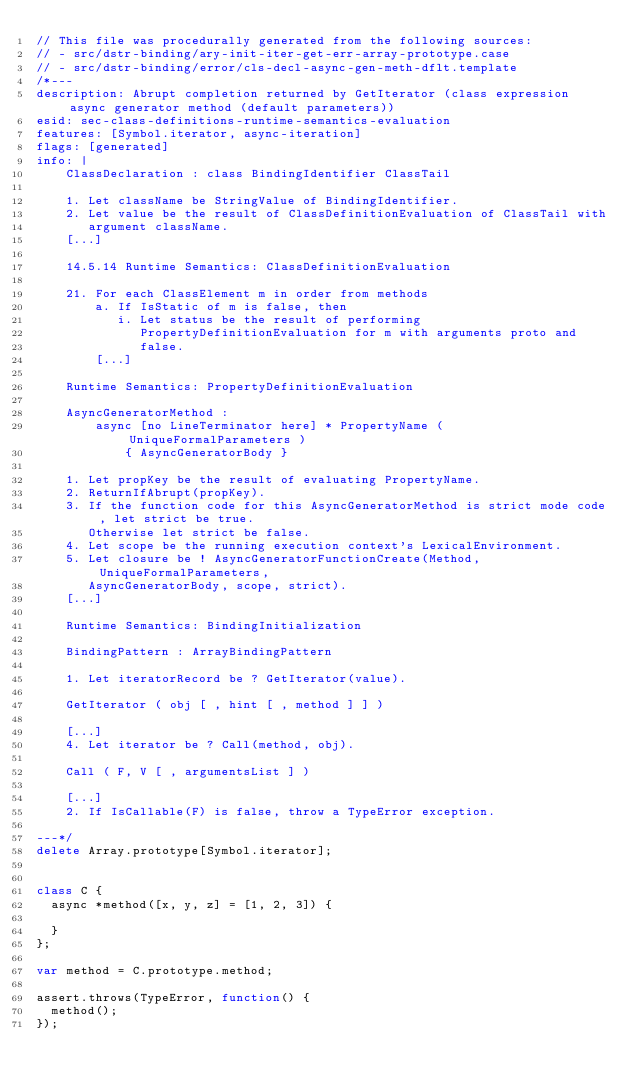<code> <loc_0><loc_0><loc_500><loc_500><_JavaScript_>// This file was procedurally generated from the following sources:
// - src/dstr-binding/ary-init-iter-get-err-array-prototype.case
// - src/dstr-binding/error/cls-decl-async-gen-meth-dflt.template
/*---
description: Abrupt completion returned by GetIterator (class expression async generator method (default parameters))
esid: sec-class-definitions-runtime-semantics-evaluation
features: [Symbol.iterator, async-iteration]
flags: [generated]
info: |
    ClassDeclaration : class BindingIdentifier ClassTail

    1. Let className be StringValue of BindingIdentifier.
    2. Let value be the result of ClassDefinitionEvaluation of ClassTail with
       argument className.
    [...]

    14.5.14 Runtime Semantics: ClassDefinitionEvaluation

    21. For each ClassElement m in order from methods
        a. If IsStatic of m is false, then
           i. Let status be the result of performing
              PropertyDefinitionEvaluation for m with arguments proto and
              false.
        [...]

    Runtime Semantics: PropertyDefinitionEvaluation

    AsyncGeneratorMethod :
        async [no LineTerminator here] * PropertyName ( UniqueFormalParameters )
            { AsyncGeneratorBody }

    1. Let propKey be the result of evaluating PropertyName.
    2. ReturnIfAbrupt(propKey).
    3. If the function code for this AsyncGeneratorMethod is strict mode code, let strict be true.
       Otherwise let strict be false.
    4. Let scope be the running execution context's LexicalEnvironment.
    5. Let closure be ! AsyncGeneratorFunctionCreate(Method, UniqueFormalParameters,
       AsyncGeneratorBody, scope, strict).
    [...]

    Runtime Semantics: BindingInitialization

    BindingPattern : ArrayBindingPattern

    1. Let iteratorRecord be ? GetIterator(value).

    GetIterator ( obj [ , hint [ , method ] ] )

    [...]
    4. Let iterator be ? Call(method, obj).

    Call ( F, V [ , argumentsList ] )

    [...]
    2. If IsCallable(F) is false, throw a TypeError exception.

---*/
delete Array.prototype[Symbol.iterator];


class C {
  async *method([x, y, z] = [1, 2, 3]) {
    
  }
};

var method = C.prototype.method;

assert.throws(TypeError, function() {
  method();
});
</code> 